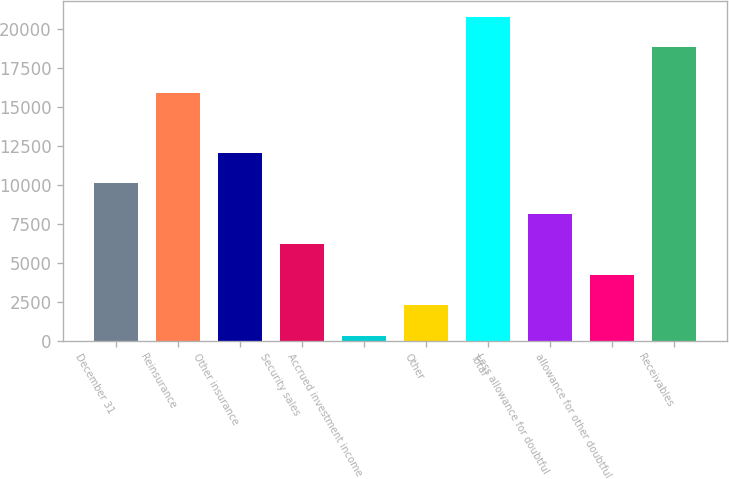<chart> <loc_0><loc_0><loc_500><loc_500><bar_chart><fcel>December 31<fcel>Reinsurance<fcel>Other insurance<fcel>Security sales<fcel>Accrued investment income<fcel>Other<fcel>Total<fcel>Less allowance for doubtful<fcel>allowance for other doubtful<fcel>Receivables<nl><fcel>10097.8<fcel>15888<fcel>12056.4<fcel>6180.64<fcel>304.9<fcel>2263.48<fcel>20792.1<fcel>8139.22<fcel>4222.06<fcel>18833.5<nl></chart> 